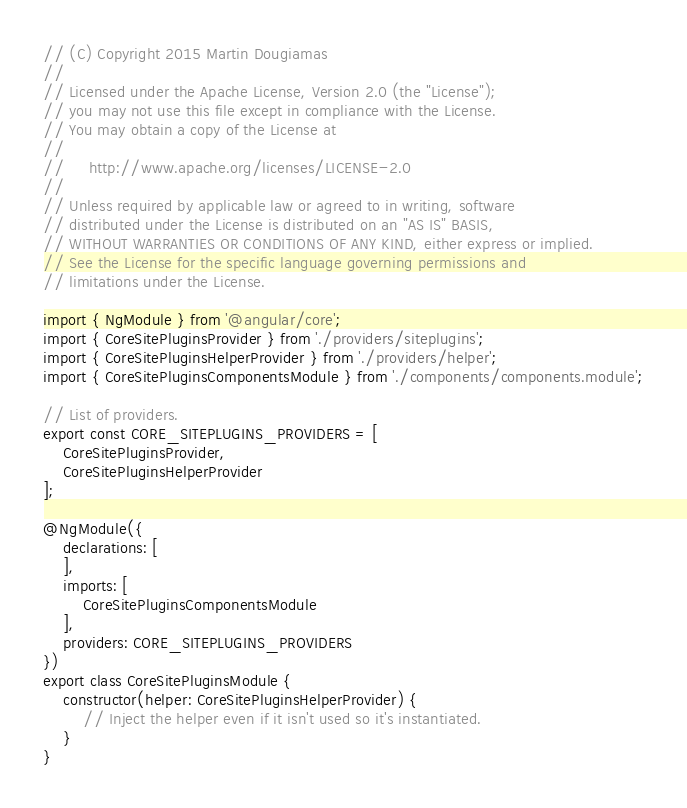<code> <loc_0><loc_0><loc_500><loc_500><_TypeScript_>// (C) Copyright 2015 Martin Dougiamas
//
// Licensed under the Apache License, Version 2.0 (the "License");
// you may not use this file except in compliance with the License.
// You may obtain a copy of the License at
//
//     http://www.apache.org/licenses/LICENSE-2.0
//
// Unless required by applicable law or agreed to in writing, software
// distributed under the License is distributed on an "AS IS" BASIS,
// WITHOUT WARRANTIES OR CONDITIONS OF ANY KIND, either express or implied.
// See the License for the specific language governing permissions and
// limitations under the License.

import { NgModule } from '@angular/core';
import { CoreSitePluginsProvider } from './providers/siteplugins';
import { CoreSitePluginsHelperProvider } from './providers/helper';
import { CoreSitePluginsComponentsModule } from './components/components.module';

// List of providers.
export const CORE_SITEPLUGINS_PROVIDERS = [
    CoreSitePluginsProvider,
    CoreSitePluginsHelperProvider
];

@NgModule({
    declarations: [
    ],
    imports: [
        CoreSitePluginsComponentsModule
    ],
    providers: CORE_SITEPLUGINS_PROVIDERS
})
export class CoreSitePluginsModule {
    constructor(helper: CoreSitePluginsHelperProvider) {
        // Inject the helper even if it isn't used so it's instantiated.
    }
}
</code> 